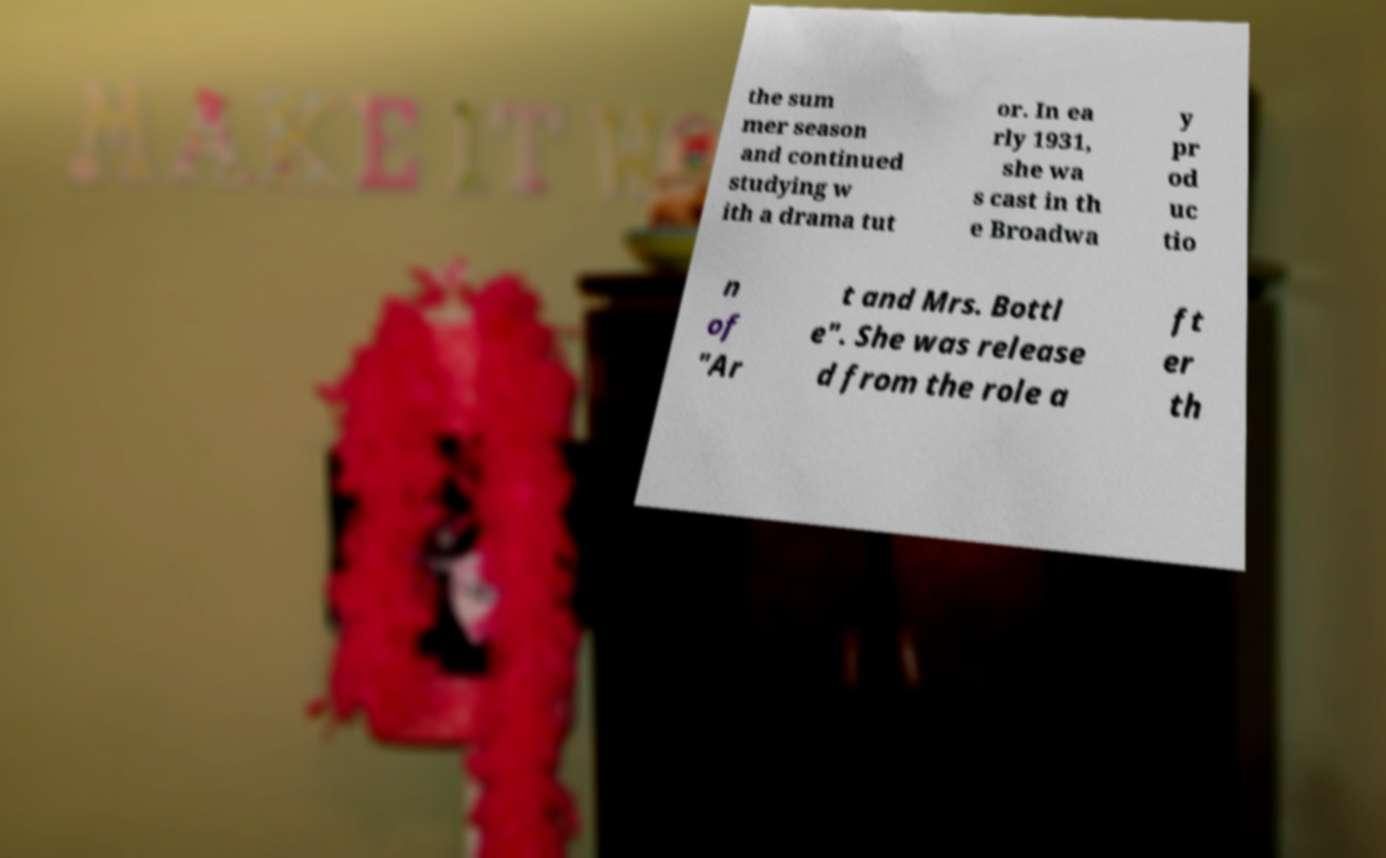For documentation purposes, I need the text within this image transcribed. Could you provide that? the sum mer season and continued studying w ith a drama tut or. In ea rly 1931, she wa s cast in th e Broadwa y pr od uc tio n of "Ar t and Mrs. Bottl e". She was release d from the role a ft er th 